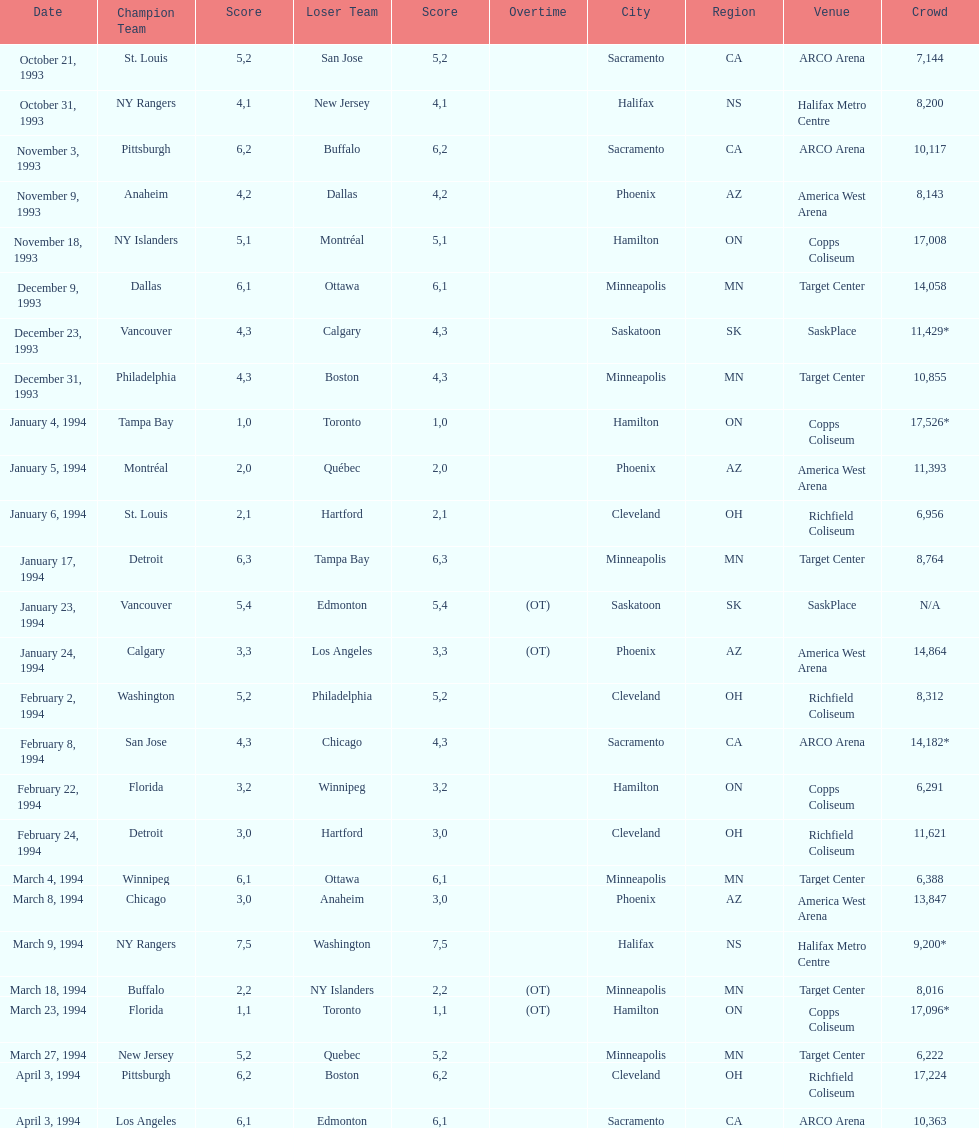When was the first neutral site game to be won by tampa bay? January 4, 1994. 